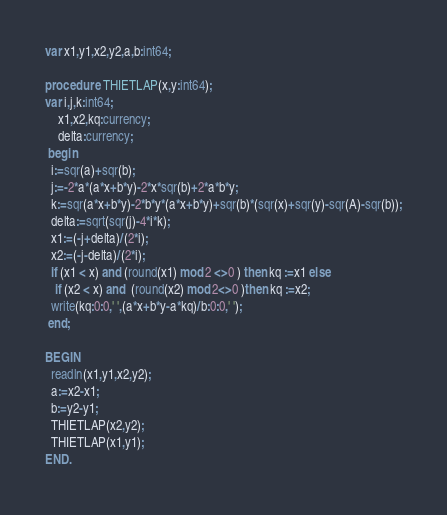<code> <loc_0><loc_0><loc_500><loc_500><_Pascal_>var x1,y1,x2,y2,a,b:int64;

procedure  THIETLAP(x,y:int64);
var i,j,k:int64;
    x1,x2,kq:currency;
    delta:currency;
 begin
  i:=sqr(a)+sqr(b);
  j:=-2*a*(a*x+b*y)-2*x*sqr(b)+2*a*b*y;
  k:=sqr(a*x+b*y)-2*b*y*(a*x+b*y)+sqr(b)*(sqr(x)+sqr(y)-sqr(A)-sqr(b));
  delta:=sqrt(sqr(j)-4*i*k);
  x1:=(-j+delta)/(2*i);
  x2:=(-j-delta)/(2*i);
  if (x1 < x) and (round(x1) mod 2 <>0 ) then kq :=x1 else 
   if (x2 < x) and  (round(x2) mod 2<>0 )then kq :=x2;
  write(kq:0:0,' ',(a*x+b*y-a*kq)/b:0:0,' ');
 end;

BEGIN
  readln(x1,y1,x2,y2);
  a:=x2-x1;
  b:=y2-y1; 
  THIETLAP(x2,y2);
  THIETLAP(x1,y1);
END.</code> 